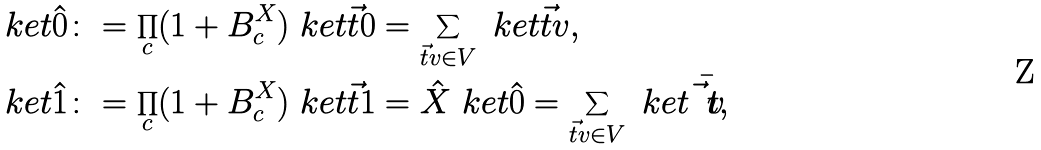<formula> <loc_0><loc_0><loc_500><loc_500>\ k e t { \hat { 0 } } & \colon = \prod _ { c } ( 1 + B _ { c } ^ { X } ) \ k e t { \vec { t } 0 } = \sum _ { \vec { t } v \in V } \ k e t { \vec { t } v } , \\ \ k e t { \hat { 1 } } & \colon = \prod _ { c } ( 1 + B _ { c } ^ { X } ) \ k e t { \vec { t } 1 } = \hat { X } \ k e t { \hat { 0 } } = \sum _ { \vec { t } v \in V } \ k e t { \bar { \vec { t } v } } ,</formula> 